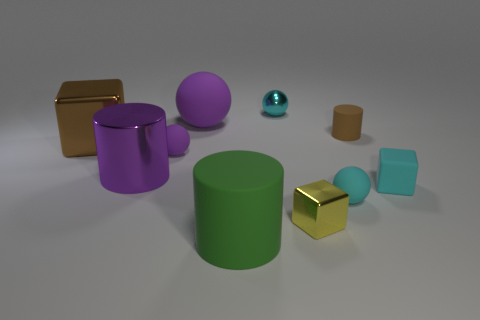Subtract all blocks. How many objects are left? 7 Add 5 large things. How many large things exist? 9 Subtract 1 cyan balls. How many objects are left? 9 Subtract all purple rubber things. Subtract all large purple matte spheres. How many objects are left? 7 Add 3 small yellow shiny blocks. How many small yellow shiny blocks are left? 4 